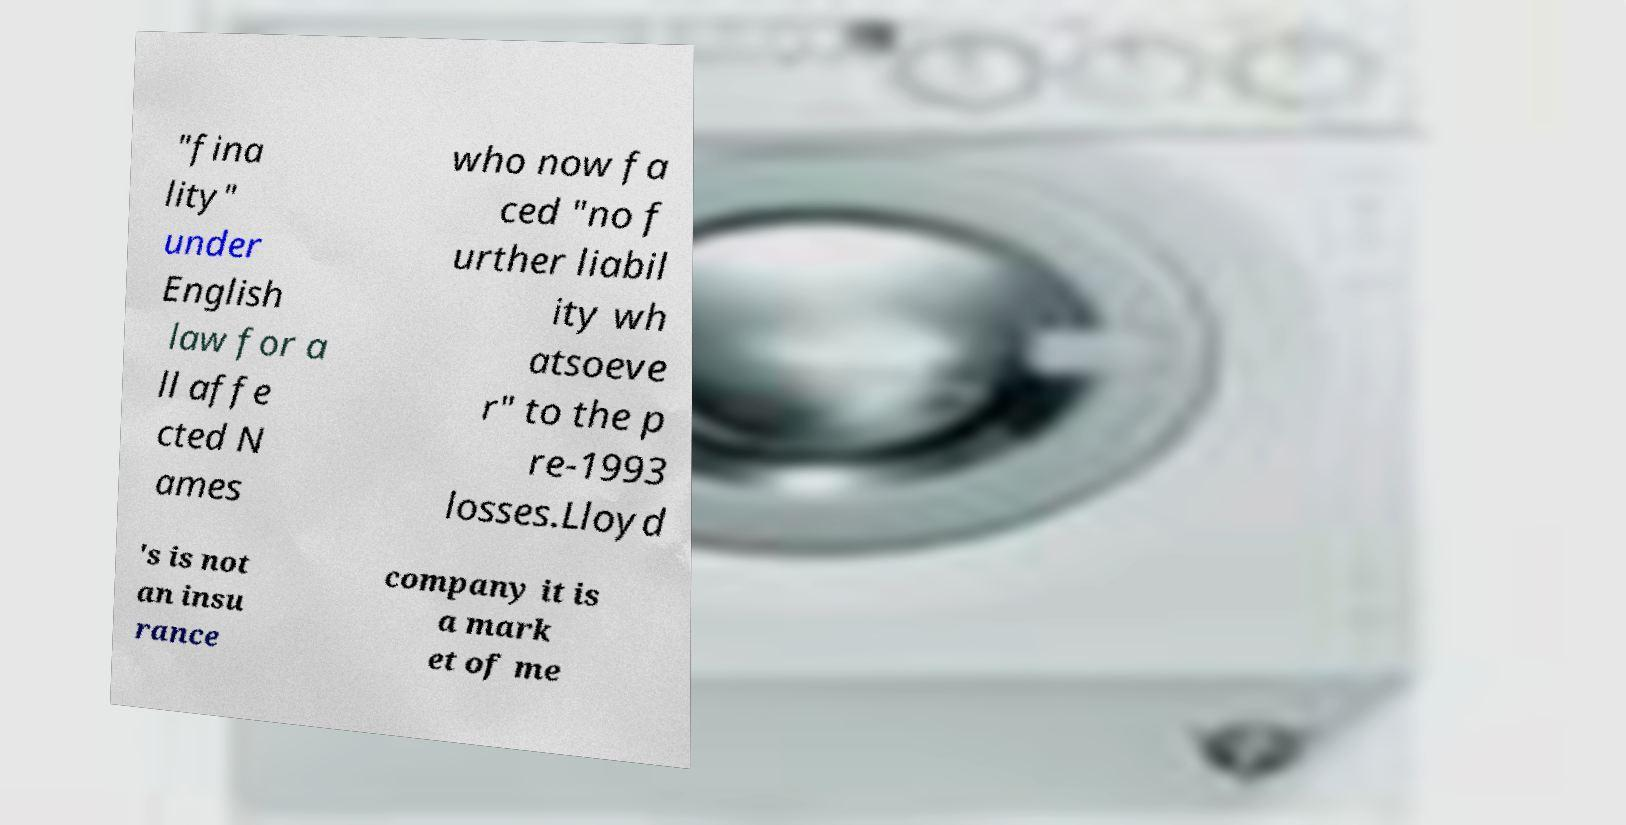Can you read and provide the text displayed in the image?This photo seems to have some interesting text. Can you extract and type it out for me? "fina lity" under English law for a ll affe cted N ames who now fa ced "no f urther liabil ity wh atsoeve r" to the p re-1993 losses.Lloyd 's is not an insu rance company it is a mark et of me 